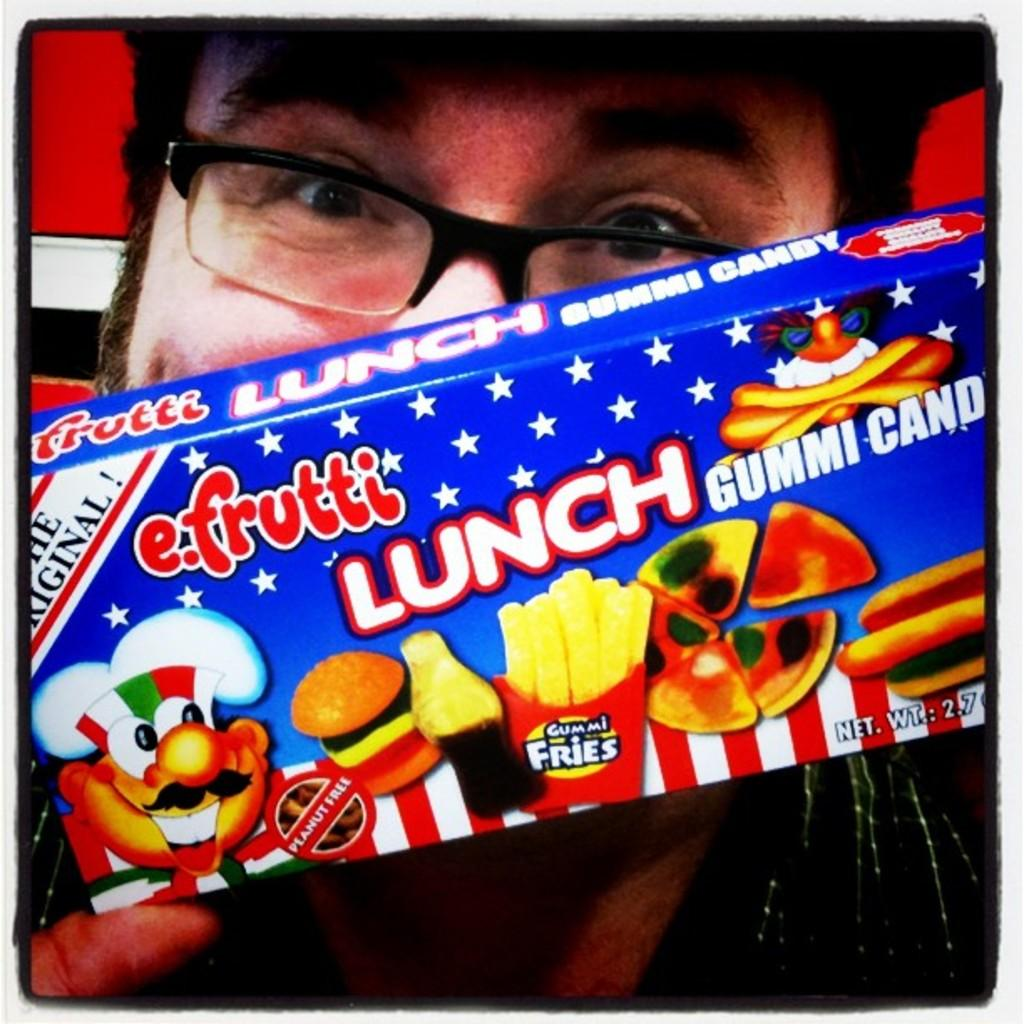What can be seen in the image? There is a person in the image. Can you describe the person's appearance? The person is wearing spectacles. What is the person holding in the image? The person is holding a box. What type of prose is the person reading in the image? There is no indication in the image that the person is reading any prose, as they are holding a box, not a book or any reading material. 